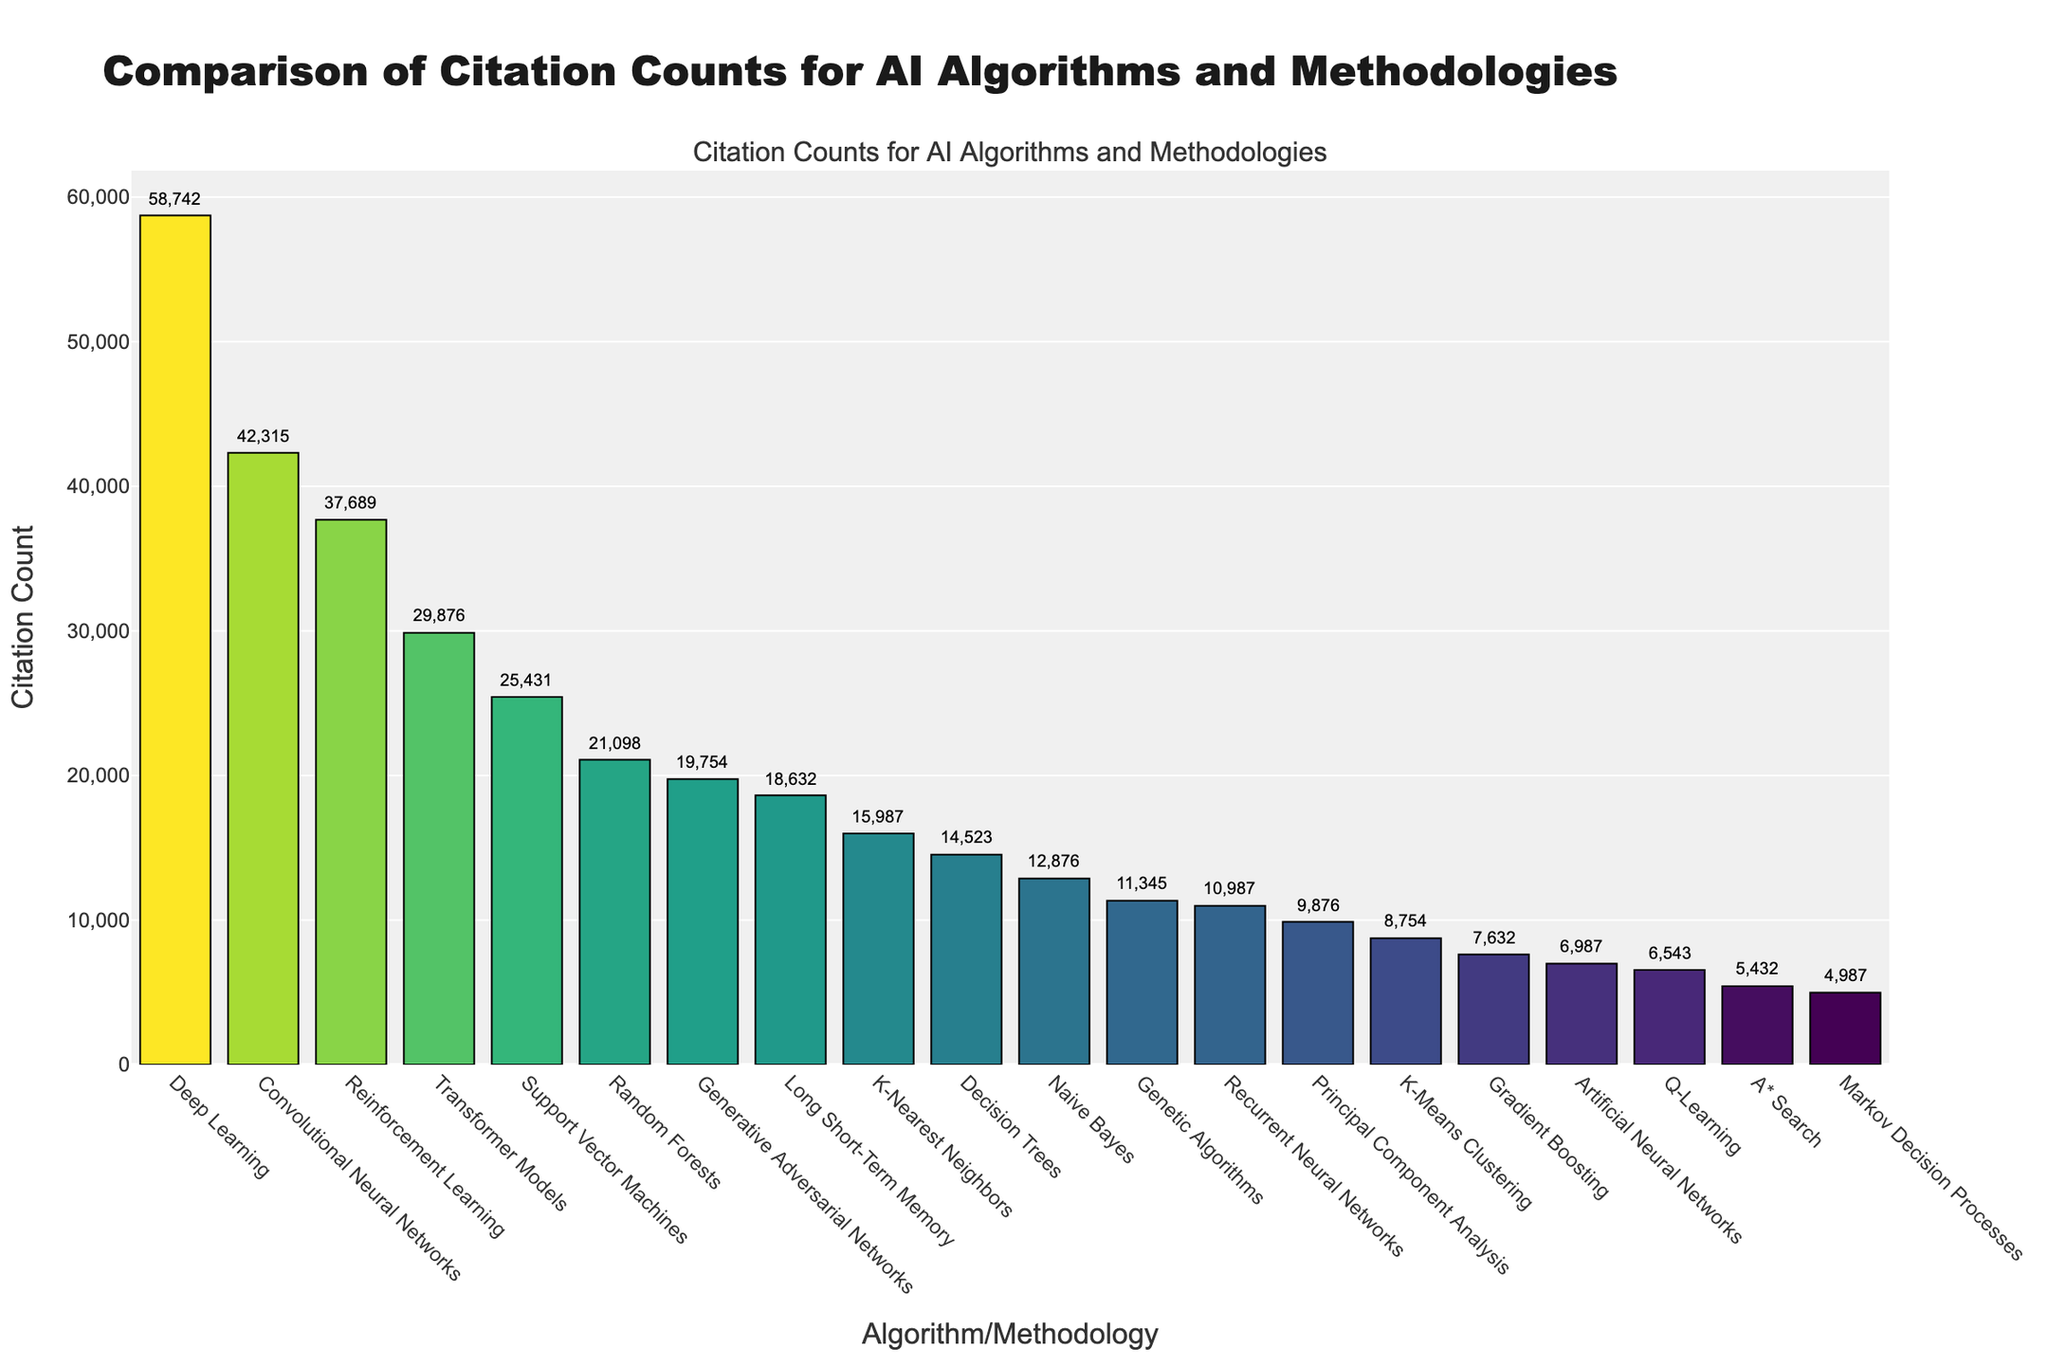Which AI algorithm has the highest citation count? The highest bar on the chart corresponds to Deep Learning, indicating it has the highest citation count.
Answer: Deep Learning Which AI algorithm has the lowest citation count? The shortest bar on the chart corresponds to Markov Decision Processes, indicating it has the lowest citation count.
Answer: Markov Decision Processes How many citations does Reinforcement Learning have as compared to Transformer Models? The bar for Reinforcement Learning is higher than the bar for Transformer Models. Reinforcement Learning has 37689 citations, while Transformer Models have 29876 citations. The difference is 37689 - 29876 = 7813
Answer: 7813 What is the combined citation count of Convolutional Neural Networks and Support Vector Machines? The citation counts are 42315 for Convolutional Neural Networks and 25431 for Support Vector Machines. Summing these two gives 42315 + 25431 = 67746
Answer: 67746 Which algorithm has more citations: Random Forests or Generative Adversarial Networks? The bar for Random Forests is higher than that for Generative Adversarial Networks. Random Forests have 21098 citations, while Generative Adversarial Networks have 19754 citations.
Answer: Random Forests What is the difference in citation count between Long Short-Term Memory and K-Nearest Neighbors? Long Short-Term Memory has 18632 citations, and K-Nearest Neighbors has 15987 citations. The difference is 18632 - 15987 = 2645
Answer: 2645 Are there any algorithms with citation counts between 10000 and 20000? If yes, name them. Referring to the citation counts in the given range, Generative Adversarial Networks (19754), Long Short-Term Memory (18632), K-Nearest Neighbors (15987), Decision Trees (14523), and Naive Bayes (12876) fall within this range.
Answer: Yes, Generative Adversarial Networks, Long Short-Term Memory, K-Nearest Neighbors, Decision Trees, Naive Bayes Which algorithm has a citation count closest to 10000? Referring to the values, Principal Component Analysis has a citation count of 9876, which is closest to 10000.
Answer: Principal Component Analysis What is the average citation count of the top three cited methodologies? The top three cited methodologies are Deep Learning (58742), Convolutional Neural Networks (42315), and Reinforcement Learning (37689). The sum is 58742 + 42315 + 37689 = 138746, and the average is 138746 / 3 = 46249
Answer: 46249 